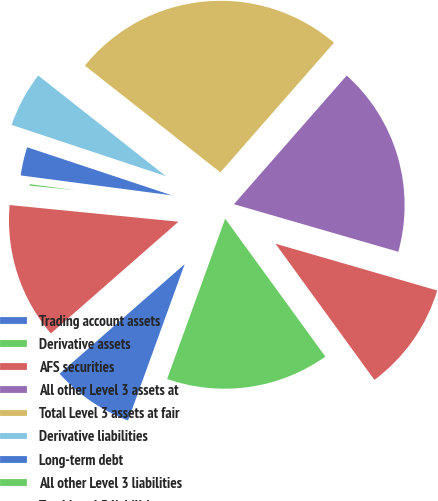Convert chart to OTSL. <chart><loc_0><loc_0><loc_500><loc_500><pie_chart><fcel>Trading account assets<fcel>Derivative assets<fcel>AFS securities<fcel>All other Level 3 assets at<fcel>Total Level 3 assets at fair<fcel>Derivative liabilities<fcel>Long-term debt<fcel>All other Level 3 liabilities<fcel>Total Level 3 liabilities at<nl><fcel>8.02%<fcel>15.53%<fcel>10.52%<fcel>18.03%<fcel>25.83%<fcel>5.52%<fcel>3.02%<fcel>0.52%<fcel>13.02%<nl></chart> 